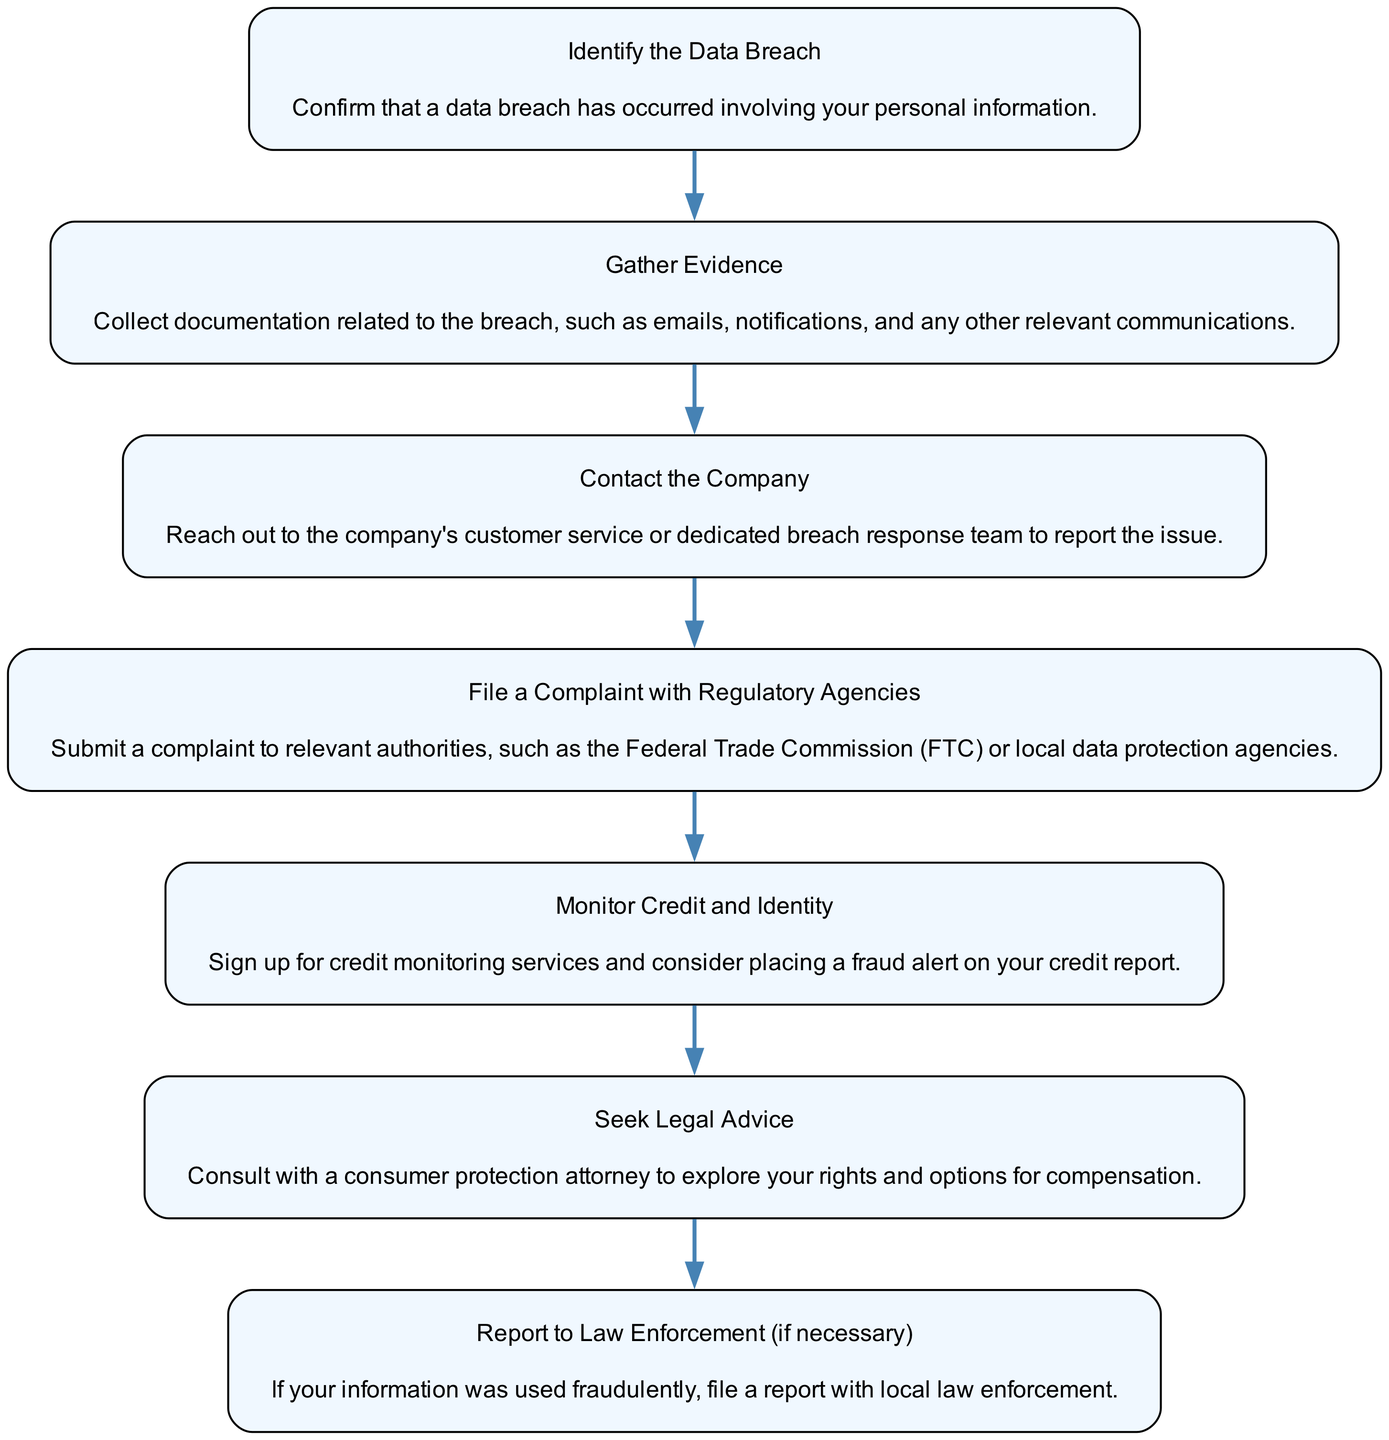What is the first step in filing a complaint after a data breach? The first step outlined in the flow chart is "Identify the Data Breach," which involves confirming that a data breach has occurred involving personal information. This is indicated as the starting point of the flow.
Answer: Identify the Data Breach How many total steps are included in the flow chart? The flow chart lists a total of seven distinct steps, each detailing a process to follow after a data breach. This can be counted by examining the nodes present in the diagram, starting from the first to the last step.
Answer: 7 Which step involves collecting documentation? The step titled "Gather Evidence" is specifically focused on collecting relevant documentation related to the breach, such as emails and notifications. This is shown as the second step in the flow chart.
Answer: Gather Evidence What should you do after contacting the company? After "Contact the Company," the next step is "File a Complaint with Regulatory Agencies." This transition shows the flow from reaching out to the company to taking further actions with relevant authorities.
Answer: File a Complaint with Regulatory Agencies What action should be taken if your information was used fraudulently? In cases where personal information has been used fraudulently, the flow chart indicates that one should "Report to Law Enforcement." This step is presented as an option if fraud is confirmed after the other steps.
Answer: Report to Law Enforcement How does one seek legal assistance according to the flow chart? To seek legal assistance, the flow chart directs individuals to "Seek Legal Advice," indicating that consulting with a consumer protection attorney is recommended to explore rights and compensation options. This is shown after monitoring credit and identity.
Answer: Seek Legal Advice What is recommended immediately after filing a complaint? The flow chart suggests "Monitor Credit and Identity" as a subsequent action to filing a complaint, indicating the need to stay vigilant regarding one’s financial information and identity after addressing the breach.
Answer: Monitor Credit and Identity 